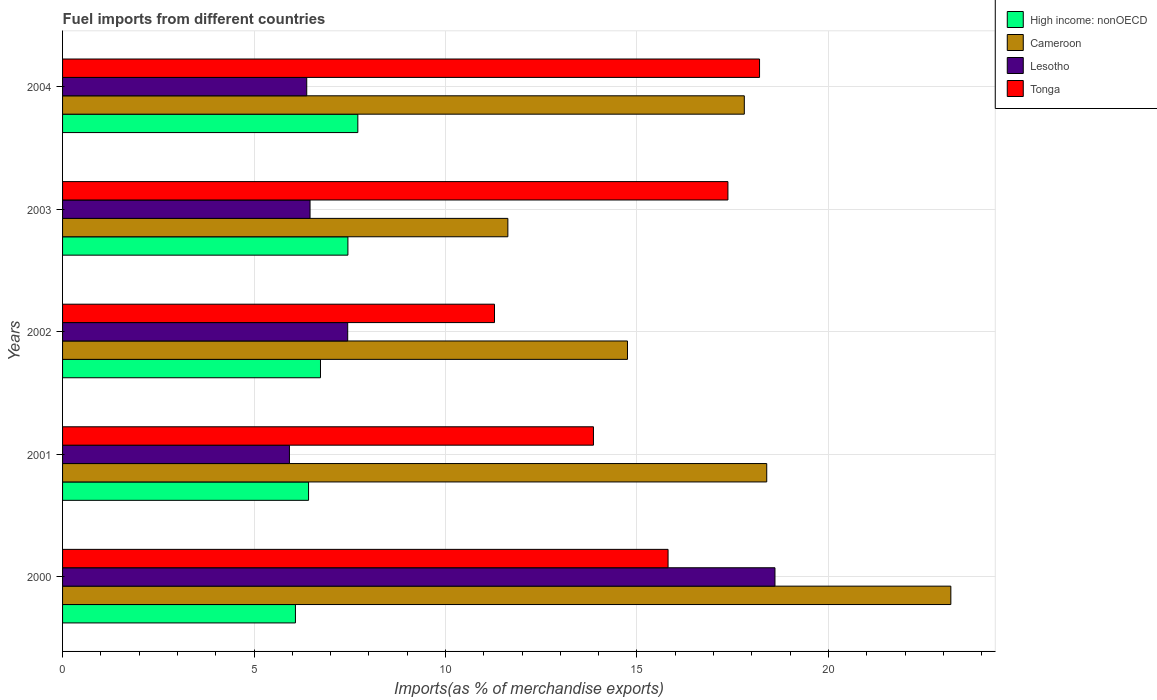How many different coloured bars are there?
Ensure brevity in your answer.  4. How many groups of bars are there?
Your answer should be very brief. 5. How many bars are there on the 2nd tick from the top?
Your answer should be compact. 4. How many bars are there on the 5th tick from the bottom?
Make the answer very short. 4. In how many cases, is the number of bars for a given year not equal to the number of legend labels?
Provide a succinct answer. 0. What is the percentage of imports to different countries in High income: nonOECD in 2004?
Your answer should be compact. 7.71. Across all years, what is the maximum percentage of imports to different countries in Cameroon?
Keep it short and to the point. 23.2. Across all years, what is the minimum percentage of imports to different countries in Tonga?
Provide a succinct answer. 11.28. What is the total percentage of imports to different countries in Tonga in the graph?
Your answer should be very brief. 76.53. What is the difference between the percentage of imports to different countries in Lesotho in 2003 and that in 2004?
Keep it short and to the point. 0.09. What is the difference between the percentage of imports to different countries in Cameroon in 2000 and the percentage of imports to different countries in Tonga in 2003?
Offer a very short reply. 5.82. What is the average percentage of imports to different countries in High income: nonOECD per year?
Provide a succinct answer. 6.88. In the year 2001, what is the difference between the percentage of imports to different countries in High income: nonOECD and percentage of imports to different countries in Tonga?
Your answer should be compact. -7.44. In how many years, is the percentage of imports to different countries in Tonga greater than 3 %?
Your answer should be compact. 5. What is the ratio of the percentage of imports to different countries in Lesotho in 2000 to that in 2002?
Offer a very short reply. 2.5. What is the difference between the highest and the second highest percentage of imports to different countries in Tonga?
Make the answer very short. 0.83. What is the difference between the highest and the lowest percentage of imports to different countries in Lesotho?
Your response must be concise. 12.68. Is the sum of the percentage of imports to different countries in Tonga in 2000 and 2002 greater than the maximum percentage of imports to different countries in Lesotho across all years?
Keep it short and to the point. Yes. Is it the case that in every year, the sum of the percentage of imports to different countries in Tonga and percentage of imports to different countries in Lesotho is greater than the sum of percentage of imports to different countries in Cameroon and percentage of imports to different countries in High income: nonOECD?
Provide a short and direct response. No. What does the 2nd bar from the top in 2003 represents?
Offer a very short reply. Lesotho. What does the 3rd bar from the bottom in 2004 represents?
Your response must be concise. Lesotho. Is it the case that in every year, the sum of the percentage of imports to different countries in Cameroon and percentage of imports to different countries in Lesotho is greater than the percentage of imports to different countries in High income: nonOECD?
Offer a very short reply. Yes. Are all the bars in the graph horizontal?
Ensure brevity in your answer.  Yes. How many years are there in the graph?
Provide a succinct answer. 5. Does the graph contain any zero values?
Provide a succinct answer. No. Where does the legend appear in the graph?
Give a very brief answer. Top right. How many legend labels are there?
Make the answer very short. 4. What is the title of the graph?
Ensure brevity in your answer.  Fuel imports from different countries. Does "Sri Lanka" appear as one of the legend labels in the graph?
Your answer should be compact. No. What is the label or title of the X-axis?
Offer a terse response. Imports(as % of merchandise exports). What is the label or title of the Y-axis?
Your answer should be very brief. Years. What is the Imports(as % of merchandise exports) of High income: nonOECD in 2000?
Give a very brief answer. 6.08. What is the Imports(as % of merchandise exports) of Cameroon in 2000?
Your answer should be compact. 23.2. What is the Imports(as % of merchandise exports) in Lesotho in 2000?
Your answer should be very brief. 18.6. What is the Imports(as % of merchandise exports) of Tonga in 2000?
Offer a terse response. 15.81. What is the Imports(as % of merchandise exports) of High income: nonOECD in 2001?
Your answer should be very brief. 6.42. What is the Imports(as % of merchandise exports) in Cameroon in 2001?
Give a very brief answer. 18.39. What is the Imports(as % of merchandise exports) of Lesotho in 2001?
Make the answer very short. 5.92. What is the Imports(as % of merchandise exports) of Tonga in 2001?
Offer a terse response. 13.86. What is the Imports(as % of merchandise exports) of High income: nonOECD in 2002?
Your answer should be compact. 6.73. What is the Imports(as % of merchandise exports) in Cameroon in 2002?
Your answer should be compact. 14.75. What is the Imports(as % of merchandise exports) in Lesotho in 2002?
Provide a succinct answer. 7.45. What is the Imports(as % of merchandise exports) of Tonga in 2002?
Keep it short and to the point. 11.28. What is the Imports(as % of merchandise exports) in High income: nonOECD in 2003?
Give a very brief answer. 7.45. What is the Imports(as % of merchandise exports) of Cameroon in 2003?
Provide a succinct answer. 11.63. What is the Imports(as % of merchandise exports) of Lesotho in 2003?
Your answer should be very brief. 6.46. What is the Imports(as % of merchandise exports) in Tonga in 2003?
Provide a succinct answer. 17.37. What is the Imports(as % of merchandise exports) in High income: nonOECD in 2004?
Give a very brief answer. 7.71. What is the Imports(as % of merchandise exports) in Cameroon in 2004?
Your answer should be very brief. 17.8. What is the Imports(as % of merchandise exports) in Lesotho in 2004?
Provide a succinct answer. 6.38. What is the Imports(as % of merchandise exports) of Tonga in 2004?
Keep it short and to the point. 18.2. Across all years, what is the maximum Imports(as % of merchandise exports) of High income: nonOECD?
Provide a short and direct response. 7.71. Across all years, what is the maximum Imports(as % of merchandise exports) in Cameroon?
Provide a succinct answer. 23.2. Across all years, what is the maximum Imports(as % of merchandise exports) in Lesotho?
Offer a very short reply. 18.6. Across all years, what is the maximum Imports(as % of merchandise exports) of Tonga?
Keep it short and to the point. 18.2. Across all years, what is the minimum Imports(as % of merchandise exports) in High income: nonOECD?
Your response must be concise. 6.08. Across all years, what is the minimum Imports(as % of merchandise exports) of Cameroon?
Give a very brief answer. 11.63. Across all years, what is the minimum Imports(as % of merchandise exports) in Lesotho?
Provide a short and direct response. 5.92. Across all years, what is the minimum Imports(as % of merchandise exports) in Tonga?
Provide a short and direct response. 11.28. What is the total Imports(as % of merchandise exports) of High income: nonOECD in the graph?
Your answer should be compact. 34.4. What is the total Imports(as % of merchandise exports) of Cameroon in the graph?
Make the answer very short. 85.77. What is the total Imports(as % of merchandise exports) of Lesotho in the graph?
Your response must be concise. 44.81. What is the total Imports(as % of merchandise exports) of Tonga in the graph?
Offer a very short reply. 76.53. What is the difference between the Imports(as % of merchandise exports) in High income: nonOECD in 2000 and that in 2001?
Provide a short and direct response. -0.34. What is the difference between the Imports(as % of merchandise exports) of Cameroon in 2000 and that in 2001?
Offer a very short reply. 4.81. What is the difference between the Imports(as % of merchandise exports) of Lesotho in 2000 and that in 2001?
Provide a succinct answer. 12.68. What is the difference between the Imports(as % of merchandise exports) of Tonga in 2000 and that in 2001?
Keep it short and to the point. 1.95. What is the difference between the Imports(as % of merchandise exports) in High income: nonOECD in 2000 and that in 2002?
Provide a succinct answer. -0.65. What is the difference between the Imports(as % of merchandise exports) in Cameroon in 2000 and that in 2002?
Keep it short and to the point. 8.44. What is the difference between the Imports(as % of merchandise exports) of Lesotho in 2000 and that in 2002?
Ensure brevity in your answer.  11.16. What is the difference between the Imports(as % of merchandise exports) of Tonga in 2000 and that in 2002?
Ensure brevity in your answer.  4.53. What is the difference between the Imports(as % of merchandise exports) of High income: nonOECD in 2000 and that in 2003?
Your answer should be compact. -1.37. What is the difference between the Imports(as % of merchandise exports) in Cameroon in 2000 and that in 2003?
Keep it short and to the point. 11.57. What is the difference between the Imports(as % of merchandise exports) of Lesotho in 2000 and that in 2003?
Make the answer very short. 12.14. What is the difference between the Imports(as % of merchandise exports) of Tonga in 2000 and that in 2003?
Your response must be concise. -1.56. What is the difference between the Imports(as % of merchandise exports) of High income: nonOECD in 2000 and that in 2004?
Offer a terse response. -1.63. What is the difference between the Imports(as % of merchandise exports) in Cameroon in 2000 and that in 2004?
Make the answer very short. 5.39. What is the difference between the Imports(as % of merchandise exports) of Lesotho in 2000 and that in 2004?
Give a very brief answer. 12.23. What is the difference between the Imports(as % of merchandise exports) in Tonga in 2000 and that in 2004?
Offer a very short reply. -2.39. What is the difference between the Imports(as % of merchandise exports) of High income: nonOECD in 2001 and that in 2002?
Give a very brief answer. -0.31. What is the difference between the Imports(as % of merchandise exports) of Cameroon in 2001 and that in 2002?
Your response must be concise. 3.64. What is the difference between the Imports(as % of merchandise exports) in Lesotho in 2001 and that in 2002?
Your answer should be compact. -1.52. What is the difference between the Imports(as % of merchandise exports) in Tonga in 2001 and that in 2002?
Offer a very short reply. 2.58. What is the difference between the Imports(as % of merchandise exports) of High income: nonOECD in 2001 and that in 2003?
Offer a very short reply. -1.03. What is the difference between the Imports(as % of merchandise exports) of Cameroon in 2001 and that in 2003?
Ensure brevity in your answer.  6.76. What is the difference between the Imports(as % of merchandise exports) of Lesotho in 2001 and that in 2003?
Ensure brevity in your answer.  -0.54. What is the difference between the Imports(as % of merchandise exports) of Tonga in 2001 and that in 2003?
Provide a short and direct response. -3.51. What is the difference between the Imports(as % of merchandise exports) in High income: nonOECD in 2001 and that in 2004?
Make the answer very short. -1.29. What is the difference between the Imports(as % of merchandise exports) in Cameroon in 2001 and that in 2004?
Give a very brief answer. 0.59. What is the difference between the Imports(as % of merchandise exports) of Lesotho in 2001 and that in 2004?
Make the answer very short. -0.45. What is the difference between the Imports(as % of merchandise exports) of Tonga in 2001 and that in 2004?
Provide a short and direct response. -4.34. What is the difference between the Imports(as % of merchandise exports) of High income: nonOECD in 2002 and that in 2003?
Offer a very short reply. -0.72. What is the difference between the Imports(as % of merchandise exports) in Cameroon in 2002 and that in 2003?
Your response must be concise. 3.12. What is the difference between the Imports(as % of merchandise exports) in Lesotho in 2002 and that in 2003?
Provide a short and direct response. 0.98. What is the difference between the Imports(as % of merchandise exports) in Tonga in 2002 and that in 2003?
Keep it short and to the point. -6.1. What is the difference between the Imports(as % of merchandise exports) in High income: nonOECD in 2002 and that in 2004?
Provide a succinct answer. -0.98. What is the difference between the Imports(as % of merchandise exports) of Cameroon in 2002 and that in 2004?
Your answer should be very brief. -3.05. What is the difference between the Imports(as % of merchandise exports) in Lesotho in 2002 and that in 2004?
Provide a short and direct response. 1.07. What is the difference between the Imports(as % of merchandise exports) of Tonga in 2002 and that in 2004?
Offer a terse response. -6.92. What is the difference between the Imports(as % of merchandise exports) of High income: nonOECD in 2003 and that in 2004?
Your response must be concise. -0.26. What is the difference between the Imports(as % of merchandise exports) of Cameroon in 2003 and that in 2004?
Keep it short and to the point. -6.17. What is the difference between the Imports(as % of merchandise exports) in Lesotho in 2003 and that in 2004?
Your answer should be very brief. 0.09. What is the difference between the Imports(as % of merchandise exports) in Tonga in 2003 and that in 2004?
Provide a short and direct response. -0.83. What is the difference between the Imports(as % of merchandise exports) of High income: nonOECD in 2000 and the Imports(as % of merchandise exports) of Cameroon in 2001?
Give a very brief answer. -12.31. What is the difference between the Imports(as % of merchandise exports) in High income: nonOECD in 2000 and the Imports(as % of merchandise exports) in Lesotho in 2001?
Offer a very short reply. 0.16. What is the difference between the Imports(as % of merchandise exports) in High income: nonOECD in 2000 and the Imports(as % of merchandise exports) in Tonga in 2001?
Keep it short and to the point. -7.78. What is the difference between the Imports(as % of merchandise exports) of Cameroon in 2000 and the Imports(as % of merchandise exports) of Lesotho in 2001?
Your answer should be compact. 17.27. What is the difference between the Imports(as % of merchandise exports) in Cameroon in 2000 and the Imports(as % of merchandise exports) in Tonga in 2001?
Keep it short and to the point. 9.33. What is the difference between the Imports(as % of merchandise exports) of Lesotho in 2000 and the Imports(as % of merchandise exports) of Tonga in 2001?
Offer a terse response. 4.74. What is the difference between the Imports(as % of merchandise exports) in High income: nonOECD in 2000 and the Imports(as % of merchandise exports) in Cameroon in 2002?
Your response must be concise. -8.67. What is the difference between the Imports(as % of merchandise exports) of High income: nonOECD in 2000 and the Imports(as % of merchandise exports) of Lesotho in 2002?
Your answer should be very brief. -1.36. What is the difference between the Imports(as % of merchandise exports) in High income: nonOECD in 2000 and the Imports(as % of merchandise exports) in Tonga in 2002?
Keep it short and to the point. -5.2. What is the difference between the Imports(as % of merchandise exports) in Cameroon in 2000 and the Imports(as % of merchandise exports) in Lesotho in 2002?
Give a very brief answer. 15.75. What is the difference between the Imports(as % of merchandise exports) in Cameroon in 2000 and the Imports(as % of merchandise exports) in Tonga in 2002?
Offer a terse response. 11.92. What is the difference between the Imports(as % of merchandise exports) in Lesotho in 2000 and the Imports(as % of merchandise exports) in Tonga in 2002?
Your answer should be very brief. 7.32. What is the difference between the Imports(as % of merchandise exports) of High income: nonOECD in 2000 and the Imports(as % of merchandise exports) of Cameroon in 2003?
Your response must be concise. -5.55. What is the difference between the Imports(as % of merchandise exports) of High income: nonOECD in 2000 and the Imports(as % of merchandise exports) of Lesotho in 2003?
Offer a very short reply. -0.38. What is the difference between the Imports(as % of merchandise exports) of High income: nonOECD in 2000 and the Imports(as % of merchandise exports) of Tonga in 2003?
Provide a short and direct response. -11.29. What is the difference between the Imports(as % of merchandise exports) of Cameroon in 2000 and the Imports(as % of merchandise exports) of Lesotho in 2003?
Give a very brief answer. 16.73. What is the difference between the Imports(as % of merchandise exports) of Cameroon in 2000 and the Imports(as % of merchandise exports) of Tonga in 2003?
Your answer should be very brief. 5.82. What is the difference between the Imports(as % of merchandise exports) in Lesotho in 2000 and the Imports(as % of merchandise exports) in Tonga in 2003?
Keep it short and to the point. 1.23. What is the difference between the Imports(as % of merchandise exports) in High income: nonOECD in 2000 and the Imports(as % of merchandise exports) in Cameroon in 2004?
Make the answer very short. -11.72. What is the difference between the Imports(as % of merchandise exports) of High income: nonOECD in 2000 and the Imports(as % of merchandise exports) of Lesotho in 2004?
Your response must be concise. -0.3. What is the difference between the Imports(as % of merchandise exports) of High income: nonOECD in 2000 and the Imports(as % of merchandise exports) of Tonga in 2004?
Provide a short and direct response. -12.12. What is the difference between the Imports(as % of merchandise exports) in Cameroon in 2000 and the Imports(as % of merchandise exports) in Lesotho in 2004?
Ensure brevity in your answer.  16.82. What is the difference between the Imports(as % of merchandise exports) of Cameroon in 2000 and the Imports(as % of merchandise exports) of Tonga in 2004?
Keep it short and to the point. 5. What is the difference between the Imports(as % of merchandise exports) of Lesotho in 2000 and the Imports(as % of merchandise exports) of Tonga in 2004?
Your response must be concise. 0.4. What is the difference between the Imports(as % of merchandise exports) of High income: nonOECD in 2001 and the Imports(as % of merchandise exports) of Cameroon in 2002?
Your response must be concise. -8.33. What is the difference between the Imports(as % of merchandise exports) of High income: nonOECD in 2001 and the Imports(as % of merchandise exports) of Lesotho in 2002?
Provide a succinct answer. -1.02. What is the difference between the Imports(as % of merchandise exports) in High income: nonOECD in 2001 and the Imports(as % of merchandise exports) in Tonga in 2002?
Give a very brief answer. -4.86. What is the difference between the Imports(as % of merchandise exports) of Cameroon in 2001 and the Imports(as % of merchandise exports) of Lesotho in 2002?
Your response must be concise. 10.94. What is the difference between the Imports(as % of merchandise exports) of Cameroon in 2001 and the Imports(as % of merchandise exports) of Tonga in 2002?
Your response must be concise. 7.11. What is the difference between the Imports(as % of merchandise exports) in Lesotho in 2001 and the Imports(as % of merchandise exports) in Tonga in 2002?
Provide a succinct answer. -5.36. What is the difference between the Imports(as % of merchandise exports) of High income: nonOECD in 2001 and the Imports(as % of merchandise exports) of Cameroon in 2003?
Ensure brevity in your answer.  -5.2. What is the difference between the Imports(as % of merchandise exports) of High income: nonOECD in 2001 and the Imports(as % of merchandise exports) of Lesotho in 2003?
Ensure brevity in your answer.  -0.04. What is the difference between the Imports(as % of merchandise exports) of High income: nonOECD in 2001 and the Imports(as % of merchandise exports) of Tonga in 2003?
Keep it short and to the point. -10.95. What is the difference between the Imports(as % of merchandise exports) in Cameroon in 2001 and the Imports(as % of merchandise exports) in Lesotho in 2003?
Ensure brevity in your answer.  11.93. What is the difference between the Imports(as % of merchandise exports) of Cameroon in 2001 and the Imports(as % of merchandise exports) of Tonga in 2003?
Make the answer very short. 1.01. What is the difference between the Imports(as % of merchandise exports) of Lesotho in 2001 and the Imports(as % of merchandise exports) of Tonga in 2003?
Your answer should be very brief. -11.45. What is the difference between the Imports(as % of merchandise exports) of High income: nonOECD in 2001 and the Imports(as % of merchandise exports) of Cameroon in 2004?
Provide a short and direct response. -11.38. What is the difference between the Imports(as % of merchandise exports) of High income: nonOECD in 2001 and the Imports(as % of merchandise exports) of Lesotho in 2004?
Make the answer very short. 0.05. What is the difference between the Imports(as % of merchandise exports) of High income: nonOECD in 2001 and the Imports(as % of merchandise exports) of Tonga in 2004?
Give a very brief answer. -11.78. What is the difference between the Imports(as % of merchandise exports) of Cameroon in 2001 and the Imports(as % of merchandise exports) of Lesotho in 2004?
Make the answer very short. 12.01. What is the difference between the Imports(as % of merchandise exports) in Cameroon in 2001 and the Imports(as % of merchandise exports) in Tonga in 2004?
Ensure brevity in your answer.  0.19. What is the difference between the Imports(as % of merchandise exports) of Lesotho in 2001 and the Imports(as % of merchandise exports) of Tonga in 2004?
Provide a succinct answer. -12.28. What is the difference between the Imports(as % of merchandise exports) of High income: nonOECD in 2002 and the Imports(as % of merchandise exports) of Cameroon in 2003?
Ensure brevity in your answer.  -4.89. What is the difference between the Imports(as % of merchandise exports) in High income: nonOECD in 2002 and the Imports(as % of merchandise exports) in Lesotho in 2003?
Give a very brief answer. 0.27. What is the difference between the Imports(as % of merchandise exports) in High income: nonOECD in 2002 and the Imports(as % of merchandise exports) in Tonga in 2003?
Provide a short and direct response. -10.64. What is the difference between the Imports(as % of merchandise exports) in Cameroon in 2002 and the Imports(as % of merchandise exports) in Lesotho in 2003?
Provide a short and direct response. 8.29. What is the difference between the Imports(as % of merchandise exports) of Cameroon in 2002 and the Imports(as % of merchandise exports) of Tonga in 2003?
Provide a short and direct response. -2.62. What is the difference between the Imports(as % of merchandise exports) in Lesotho in 2002 and the Imports(as % of merchandise exports) in Tonga in 2003?
Your answer should be compact. -9.93. What is the difference between the Imports(as % of merchandise exports) in High income: nonOECD in 2002 and the Imports(as % of merchandise exports) in Cameroon in 2004?
Provide a short and direct response. -11.07. What is the difference between the Imports(as % of merchandise exports) of High income: nonOECD in 2002 and the Imports(as % of merchandise exports) of Lesotho in 2004?
Give a very brief answer. 0.36. What is the difference between the Imports(as % of merchandise exports) of High income: nonOECD in 2002 and the Imports(as % of merchandise exports) of Tonga in 2004?
Give a very brief answer. -11.47. What is the difference between the Imports(as % of merchandise exports) in Cameroon in 2002 and the Imports(as % of merchandise exports) in Lesotho in 2004?
Make the answer very short. 8.38. What is the difference between the Imports(as % of merchandise exports) in Cameroon in 2002 and the Imports(as % of merchandise exports) in Tonga in 2004?
Your answer should be compact. -3.45. What is the difference between the Imports(as % of merchandise exports) of Lesotho in 2002 and the Imports(as % of merchandise exports) of Tonga in 2004?
Your answer should be very brief. -10.75. What is the difference between the Imports(as % of merchandise exports) of High income: nonOECD in 2003 and the Imports(as % of merchandise exports) of Cameroon in 2004?
Offer a terse response. -10.35. What is the difference between the Imports(as % of merchandise exports) of High income: nonOECD in 2003 and the Imports(as % of merchandise exports) of Lesotho in 2004?
Offer a very short reply. 1.08. What is the difference between the Imports(as % of merchandise exports) of High income: nonOECD in 2003 and the Imports(as % of merchandise exports) of Tonga in 2004?
Your answer should be very brief. -10.75. What is the difference between the Imports(as % of merchandise exports) in Cameroon in 2003 and the Imports(as % of merchandise exports) in Lesotho in 2004?
Make the answer very short. 5.25. What is the difference between the Imports(as % of merchandise exports) of Cameroon in 2003 and the Imports(as % of merchandise exports) of Tonga in 2004?
Ensure brevity in your answer.  -6.57. What is the difference between the Imports(as % of merchandise exports) of Lesotho in 2003 and the Imports(as % of merchandise exports) of Tonga in 2004?
Make the answer very short. -11.74. What is the average Imports(as % of merchandise exports) of High income: nonOECD per year?
Make the answer very short. 6.88. What is the average Imports(as % of merchandise exports) of Cameroon per year?
Provide a short and direct response. 17.15. What is the average Imports(as % of merchandise exports) in Lesotho per year?
Provide a short and direct response. 8.96. What is the average Imports(as % of merchandise exports) in Tonga per year?
Offer a terse response. 15.31. In the year 2000, what is the difference between the Imports(as % of merchandise exports) in High income: nonOECD and Imports(as % of merchandise exports) in Cameroon?
Your answer should be compact. -17.12. In the year 2000, what is the difference between the Imports(as % of merchandise exports) in High income: nonOECD and Imports(as % of merchandise exports) in Lesotho?
Offer a terse response. -12.52. In the year 2000, what is the difference between the Imports(as % of merchandise exports) of High income: nonOECD and Imports(as % of merchandise exports) of Tonga?
Keep it short and to the point. -9.73. In the year 2000, what is the difference between the Imports(as % of merchandise exports) of Cameroon and Imports(as % of merchandise exports) of Lesotho?
Give a very brief answer. 4.59. In the year 2000, what is the difference between the Imports(as % of merchandise exports) of Cameroon and Imports(as % of merchandise exports) of Tonga?
Your answer should be very brief. 7.38. In the year 2000, what is the difference between the Imports(as % of merchandise exports) of Lesotho and Imports(as % of merchandise exports) of Tonga?
Your answer should be very brief. 2.79. In the year 2001, what is the difference between the Imports(as % of merchandise exports) of High income: nonOECD and Imports(as % of merchandise exports) of Cameroon?
Keep it short and to the point. -11.96. In the year 2001, what is the difference between the Imports(as % of merchandise exports) of High income: nonOECD and Imports(as % of merchandise exports) of Lesotho?
Your answer should be very brief. 0.5. In the year 2001, what is the difference between the Imports(as % of merchandise exports) of High income: nonOECD and Imports(as % of merchandise exports) of Tonga?
Your answer should be compact. -7.44. In the year 2001, what is the difference between the Imports(as % of merchandise exports) in Cameroon and Imports(as % of merchandise exports) in Lesotho?
Provide a succinct answer. 12.46. In the year 2001, what is the difference between the Imports(as % of merchandise exports) in Cameroon and Imports(as % of merchandise exports) in Tonga?
Make the answer very short. 4.53. In the year 2001, what is the difference between the Imports(as % of merchandise exports) of Lesotho and Imports(as % of merchandise exports) of Tonga?
Your answer should be very brief. -7.94. In the year 2002, what is the difference between the Imports(as % of merchandise exports) in High income: nonOECD and Imports(as % of merchandise exports) in Cameroon?
Your response must be concise. -8.02. In the year 2002, what is the difference between the Imports(as % of merchandise exports) of High income: nonOECD and Imports(as % of merchandise exports) of Lesotho?
Ensure brevity in your answer.  -0.71. In the year 2002, what is the difference between the Imports(as % of merchandise exports) in High income: nonOECD and Imports(as % of merchandise exports) in Tonga?
Offer a very short reply. -4.54. In the year 2002, what is the difference between the Imports(as % of merchandise exports) in Cameroon and Imports(as % of merchandise exports) in Lesotho?
Your answer should be very brief. 7.31. In the year 2002, what is the difference between the Imports(as % of merchandise exports) in Cameroon and Imports(as % of merchandise exports) in Tonga?
Offer a very short reply. 3.47. In the year 2002, what is the difference between the Imports(as % of merchandise exports) in Lesotho and Imports(as % of merchandise exports) in Tonga?
Your answer should be compact. -3.83. In the year 2003, what is the difference between the Imports(as % of merchandise exports) of High income: nonOECD and Imports(as % of merchandise exports) of Cameroon?
Provide a short and direct response. -4.18. In the year 2003, what is the difference between the Imports(as % of merchandise exports) in High income: nonOECD and Imports(as % of merchandise exports) in Lesotho?
Offer a terse response. 0.99. In the year 2003, what is the difference between the Imports(as % of merchandise exports) of High income: nonOECD and Imports(as % of merchandise exports) of Tonga?
Your answer should be compact. -9.92. In the year 2003, what is the difference between the Imports(as % of merchandise exports) in Cameroon and Imports(as % of merchandise exports) in Lesotho?
Make the answer very short. 5.17. In the year 2003, what is the difference between the Imports(as % of merchandise exports) in Cameroon and Imports(as % of merchandise exports) in Tonga?
Ensure brevity in your answer.  -5.75. In the year 2003, what is the difference between the Imports(as % of merchandise exports) in Lesotho and Imports(as % of merchandise exports) in Tonga?
Provide a succinct answer. -10.91. In the year 2004, what is the difference between the Imports(as % of merchandise exports) in High income: nonOECD and Imports(as % of merchandise exports) in Cameroon?
Provide a short and direct response. -10.09. In the year 2004, what is the difference between the Imports(as % of merchandise exports) of High income: nonOECD and Imports(as % of merchandise exports) of Lesotho?
Keep it short and to the point. 1.33. In the year 2004, what is the difference between the Imports(as % of merchandise exports) of High income: nonOECD and Imports(as % of merchandise exports) of Tonga?
Provide a short and direct response. -10.49. In the year 2004, what is the difference between the Imports(as % of merchandise exports) of Cameroon and Imports(as % of merchandise exports) of Lesotho?
Make the answer very short. 11.43. In the year 2004, what is the difference between the Imports(as % of merchandise exports) in Cameroon and Imports(as % of merchandise exports) in Tonga?
Provide a short and direct response. -0.4. In the year 2004, what is the difference between the Imports(as % of merchandise exports) in Lesotho and Imports(as % of merchandise exports) in Tonga?
Ensure brevity in your answer.  -11.82. What is the ratio of the Imports(as % of merchandise exports) of High income: nonOECD in 2000 to that in 2001?
Offer a terse response. 0.95. What is the ratio of the Imports(as % of merchandise exports) of Cameroon in 2000 to that in 2001?
Give a very brief answer. 1.26. What is the ratio of the Imports(as % of merchandise exports) in Lesotho in 2000 to that in 2001?
Provide a short and direct response. 3.14. What is the ratio of the Imports(as % of merchandise exports) in Tonga in 2000 to that in 2001?
Provide a succinct answer. 1.14. What is the ratio of the Imports(as % of merchandise exports) of High income: nonOECD in 2000 to that in 2002?
Provide a short and direct response. 0.9. What is the ratio of the Imports(as % of merchandise exports) in Cameroon in 2000 to that in 2002?
Give a very brief answer. 1.57. What is the ratio of the Imports(as % of merchandise exports) of Lesotho in 2000 to that in 2002?
Your answer should be compact. 2.5. What is the ratio of the Imports(as % of merchandise exports) of Tonga in 2000 to that in 2002?
Give a very brief answer. 1.4. What is the ratio of the Imports(as % of merchandise exports) of High income: nonOECD in 2000 to that in 2003?
Your answer should be compact. 0.82. What is the ratio of the Imports(as % of merchandise exports) in Cameroon in 2000 to that in 2003?
Provide a short and direct response. 1.99. What is the ratio of the Imports(as % of merchandise exports) of Lesotho in 2000 to that in 2003?
Offer a very short reply. 2.88. What is the ratio of the Imports(as % of merchandise exports) of Tonga in 2000 to that in 2003?
Your response must be concise. 0.91. What is the ratio of the Imports(as % of merchandise exports) in High income: nonOECD in 2000 to that in 2004?
Provide a succinct answer. 0.79. What is the ratio of the Imports(as % of merchandise exports) of Cameroon in 2000 to that in 2004?
Keep it short and to the point. 1.3. What is the ratio of the Imports(as % of merchandise exports) of Lesotho in 2000 to that in 2004?
Give a very brief answer. 2.92. What is the ratio of the Imports(as % of merchandise exports) in Tonga in 2000 to that in 2004?
Ensure brevity in your answer.  0.87. What is the ratio of the Imports(as % of merchandise exports) in High income: nonOECD in 2001 to that in 2002?
Offer a very short reply. 0.95. What is the ratio of the Imports(as % of merchandise exports) in Cameroon in 2001 to that in 2002?
Your answer should be compact. 1.25. What is the ratio of the Imports(as % of merchandise exports) of Lesotho in 2001 to that in 2002?
Ensure brevity in your answer.  0.8. What is the ratio of the Imports(as % of merchandise exports) of Tonga in 2001 to that in 2002?
Make the answer very short. 1.23. What is the ratio of the Imports(as % of merchandise exports) in High income: nonOECD in 2001 to that in 2003?
Offer a very short reply. 0.86. What is the ratio of the Imports(as % of merchandise exports) in Cameroon in 2001 to that in 2003?
Provide a short and direct response. 1.58. What is the ratio of the Imports(as % of merchandise exports) in Tonga in 2001 to that in 2003?
Make the answer very short. 0.8. What is the ratio of the Imports(as % of merchandise exports) of High income: nonOECD in 2001 to that in 2004?
Make the answer very short. 0.83. What is the ratio of the Imports(as % of merchandise exports) of Cameroon in 2001 to that in 2004?
Provide a short and direct response. 1.03. What is the ratio of the Imports(as % of merchandise exports) of Lesotho in 2001 to that in 2004?
Ensure brevity in your answer.  0.93. What is the ratio of the Imports(as % of merchandise exports) of Tonga in 2001 to that in 2004?
Offer a very short reply. 0.76. What is the ratio of the Imports(as % of merchandise exports) in High income: nonOECD in 2002 to that in 2003?
Offer a terse response. 0.9. What is the ratio of the Imports(as % of merchandise exports) of Cameroon in 2002 to that in 2003?
Offer a terse response. 1.27. What is the ratio of the Imports(as % of merchandise exports) in Lesotho in 2002 to that in 2003?
Ensure brevity in your answer.  1.15. What is the ratio of the Imports(as % of merchandise exports) of Tonga in 2002 to that in 2003?
Offer a very short reply. 0.65. What is the ratio of the Imports(as % of merchandise exports) in High income: nonOECD in 2002 to that in 2004?
Provide a succinct answer. 0.87. What is the ratio of the Imports(as % of merchandise exports) in Cameroon in 2002 to that in 2004?
Your answer should be compact. 0.83. What is the ratio of the Imports(as % of merchandise exports) in Lesotho in 2002 to that in 2004?
Offer a terse response. 1.17. What is the ratio of the Imports(as % of merchandise exports) in Tonga in 2002 to that in 2004?
Offer a terse response. 0.62. What is the ratio of the Imports(as % of merchandise exports) of High income: nonOECD in 2003 to that in 2004?
Offer a terse response. 0.97. What is the ratio of the Imports(as % of merchandise exports) of Cameroon in 2003 to that in 2004?
Provide a succinct answer. 0.65. What is the ratio of the Imports(as % of merchandise exports) in Lesotho in 2003 to that in 2004?
Your answer should be very brief. 1.01. What is the ratio of the Imports(as % of merchandise exports) of Tonga in 2003 to that in 2004?
Your answer should be compact. 0.95. What is the difference between the highest and the second highest Imports(as % of merchandise exports) of High income: nonOECD?
Offer a very short reply. 0.26. What is the difference between the highest and the second highest Imports(as % of merchandise exports) of Cameroon?
Your answer should be compact. 4.81. What is the difference between the highest and the second highest Imports(as % of merchandise exports) of Lesotho?
Offer a very short reply. 11.16. What is the difference between the highest and the second highest Imports(as % of merchandise exports) in Tonga?
Offer a terse response. 0.83. What is the difference between the highest and the lowest Imports(as % of merchandise exports) in High income: nonOECD?
Your response must be concise. 1.63. What is the difference between the highest and the lowest Imports(as % of merchandise exports) of Cameroon?
Ensure brevity in your answer.  11.57. What is the difference between the highest and the lowest Imports(as % of merchandise exports) in Lesotho?
Provide a succinct answer. 12.68. What is the difference between the highest and the lowest Imports(as % of merchandise exports) of Tonga?
Keep it short and to the point. 6.92. 